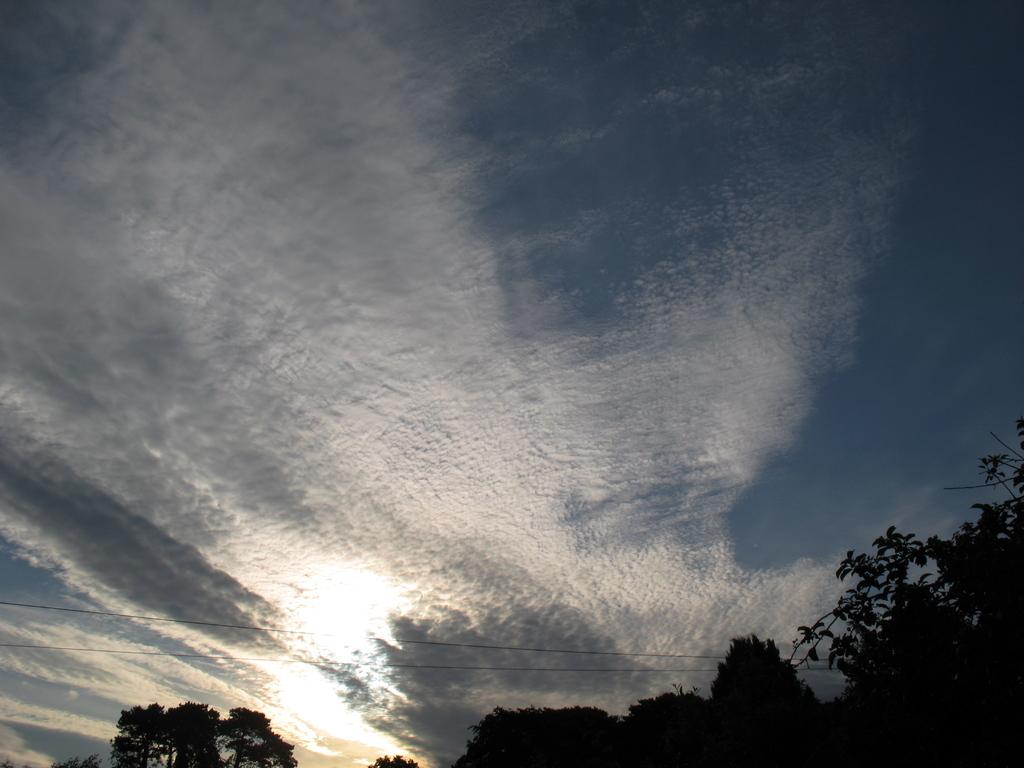What type of vegetation is in the foreground of the image? There are trees in the foreground of the image. What can be seen in the center of the image? There are wires in the center of the image. What is visible at the top of the image? Sky is visible at the top of the image. What type of lumber is being transported through the gate in the image? There is no lumber or gate present in the image; it only features trees, wires, and sky. What is the power source for the wires in the image? The image does not provide information about the power source for the wires. 